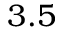<formula> <loc_0><loc_0><loc_500><loc_500>3 . 5</formula> 